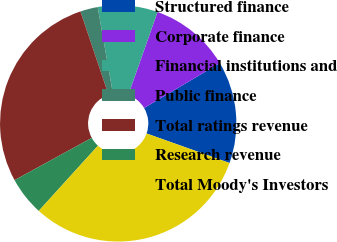<chart> <loc_0><loc_0><loc_500><loc_500><pie_chart><fcel>Structured finance<fcel>Corporate finance<fcel>Financial institutions and<fcel>Public finance<fcel>Total ratings revenue<fcel>Research revenue<fcel>Total Moody's Investors<nl><fcel>13.96%<fcel>11.07%<fcel>8.18%<fcel>2.4%<fcel>27.79%<fcel>5.29%<fcel>31.29%<nl></chart> 